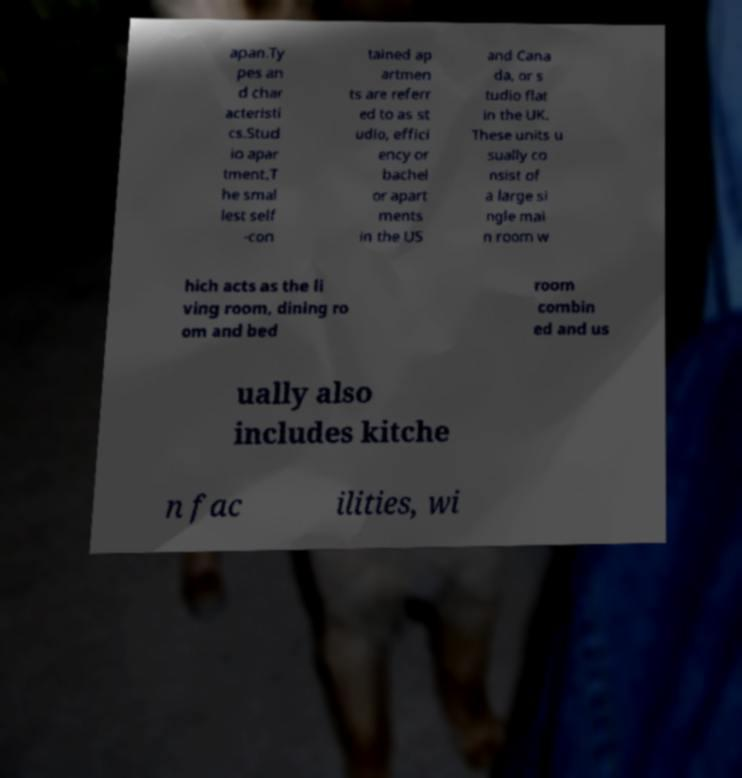What messages or text are displayed in this image? I need them in a readable, typed format. apan.Ty pes an d char acteristi cs.Stud io apar tment.T he smal lest self -con tained ap artmen ts are referr ed to as st udio, effici ency or bachel or apart ments in the US and Cana da, or s tudio flat in the UK. These units u sually co nsist of a large si ngle mai n room w hich acts as the li ving room, dining ro om and bed room combin ed and us ually also includes kitche n fac ilities, wi 